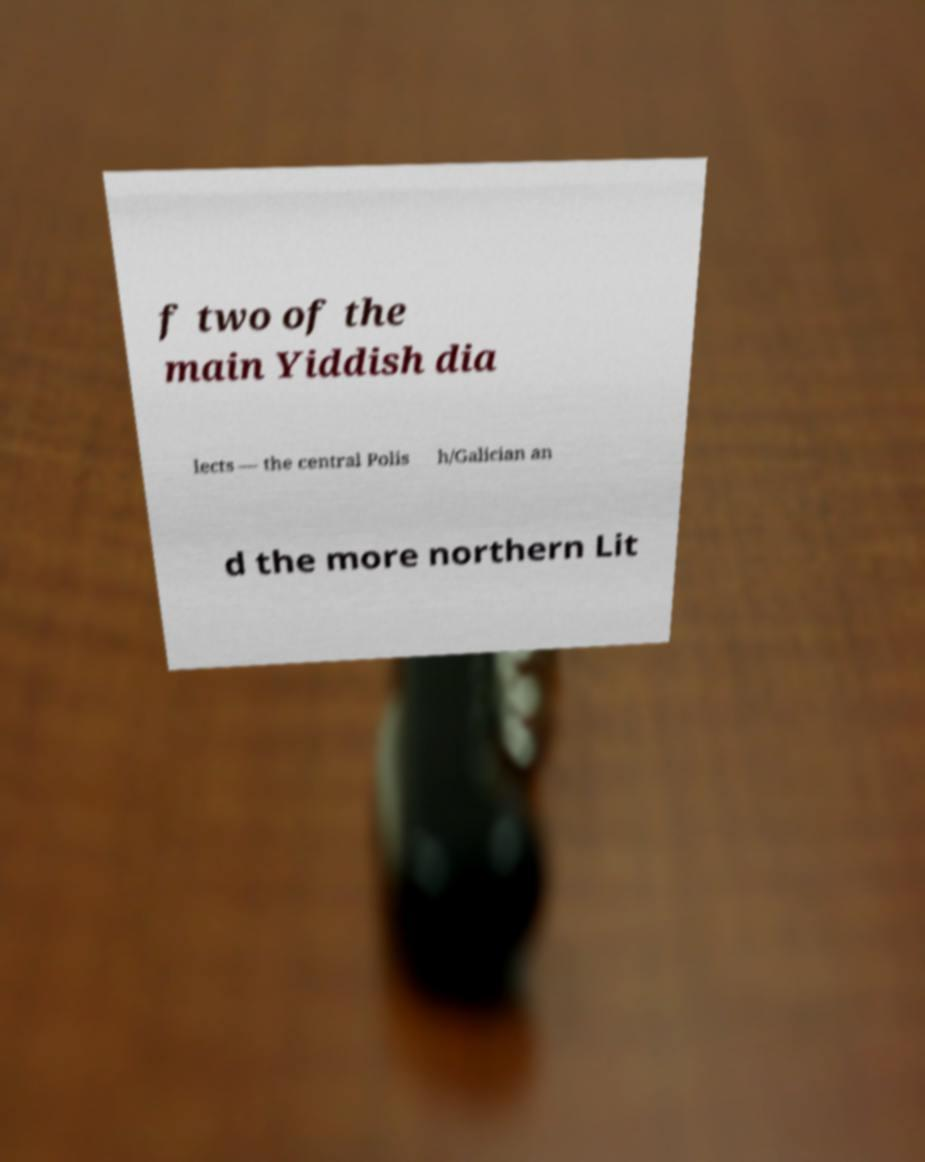There's text embedded in this image that I need extracted. Can you transcribe it verbatim? f two of the main Yiddish dia lects — the central Polis h/Galician an d the more northern Lit 